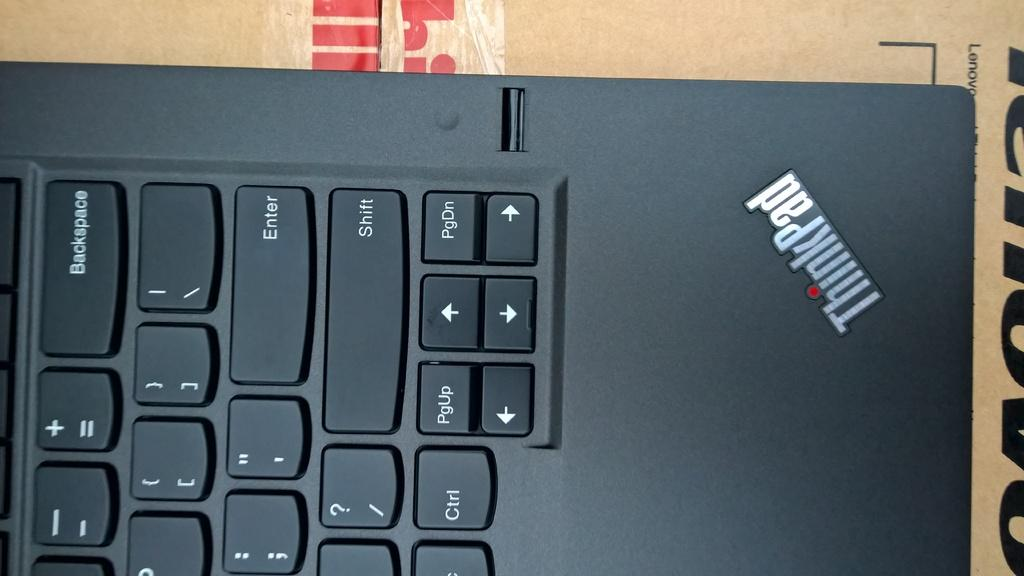<image>
Share a concise interpretation of the image provided. A ThinkPad computer is sitting on top of a Lenovo box 